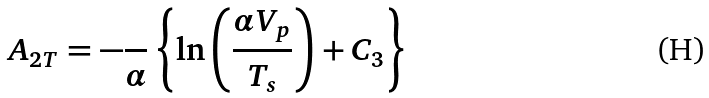Convert formula to latex. <formula><loc_0><loc_0><loc_500><loc_500>A _ { 2 T } = - \frac { } { \alpha } \left \{ \ln \left ( \frac { \alpha V _ { p } } { T _ { s } } \right ) + C _ { 3 } \right \}</formula> 